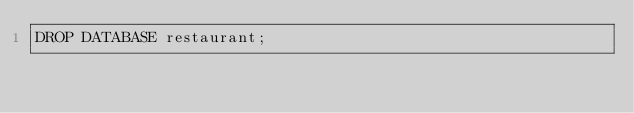<code> <loc_0><loc_0><loc_500><loc_500><_SQL_>DROP DATABASE restaurant;
</code> 